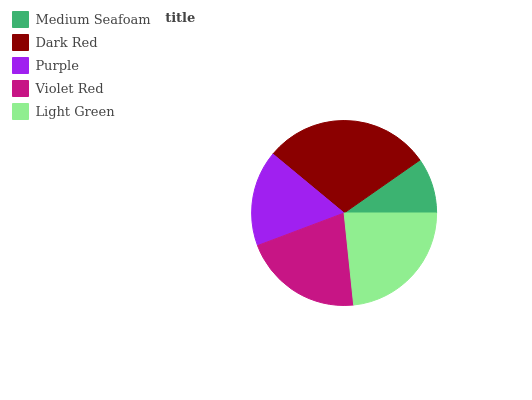Is Medium Seafoam the minimum?
Answer yes or no. Yes. Is Dark Red the maximum?
Answer yes or no. Yes. Is Purple the minimum?
Answer yes or no. No. Is Purple the maximum?
Answer yes or no. No. Is Dark Red greater than Purple?
Answer yes or no. Yes. Is Purple less than Dark Red?
Answer yes or no. Yes. Is Purple greater than Dark Red?
Answer yes or no. No. Is Dark Red less than Purple?
Answer yes or no. No. Is Violet Red the high median?
Answer yes or no. Yes. Is Violet Red the low median?
Answer yes or no. Yes. Is Dark Red the high median?
Answer yes or no. No. Is Purple the low median?
Answer yes or no. No. 